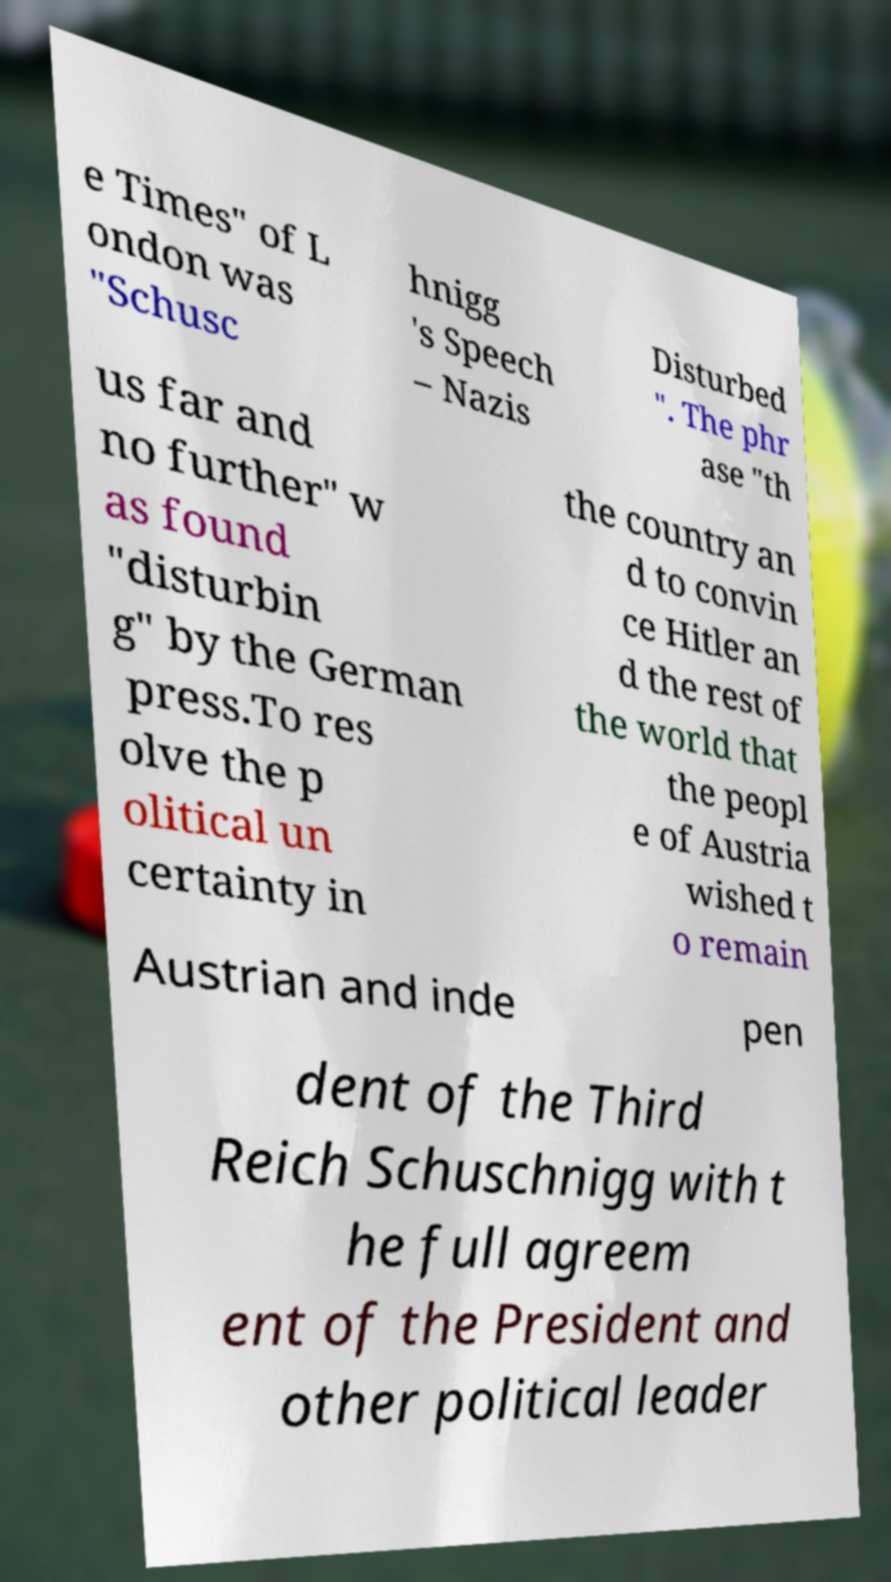Could you assist in decoding the text presented in this image and type it out clearly? e Times" of L ondon was "Schusc hnigg 's Speech – Nazis Disturbed ". The phr ase "th us far and no further" w as found "disturbin g" by the German press.To res olve the p olitical un certainty in the country an d to convin ce Hitler an d the rest of the world that the peopl e of Austria wished t o remain Austrian and inde pen dent of the Third Reich Schuschnigg with t he full agreem ent of the President and other political leader 